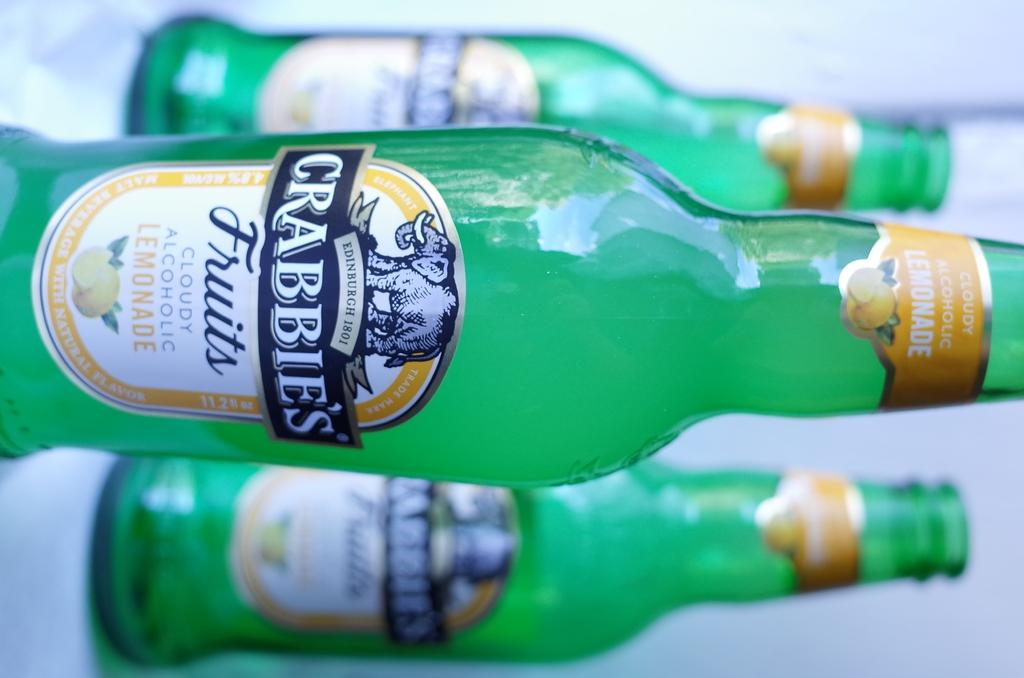<image>
Relay a brief, clear account of the picture shown. bottles of crabbies fruits cloudy alcoholic lemonade next to one another 